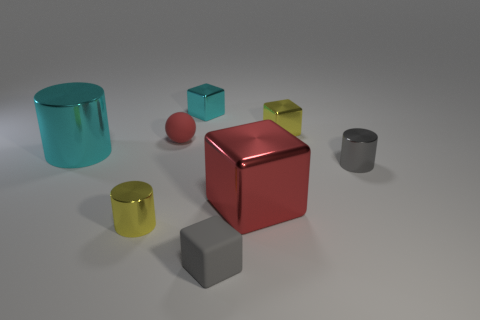Add 2 big blue cubes. How many objects exist? 10 Subtract all cylinders. How many objects are left? 5 Subtract all tiny yellow blocks. Subtract all rubber cubes. How many objects are left? 6 Add 8 yellow shiny objects. How many yellow shiny objects are left? 10 Add 3 tiny yellow cubes. How many tiny yellow cubes exist? 4 Subtract 0 brown cylinders. How many objects are left? 8 